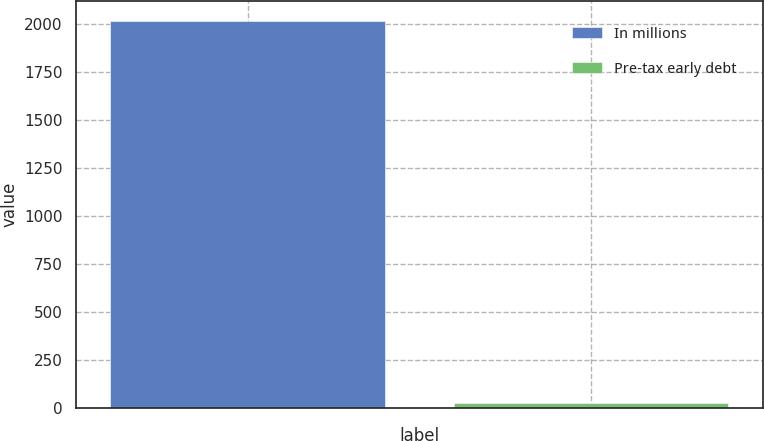Convert chart to OTSL. <chart><loc_0><loc_0><loc_500><loc_500><bar_chart><fcel>In millions<fcel>Pre-tax early debt<nl><fcel>2016<fcel>29<nl></chart> 